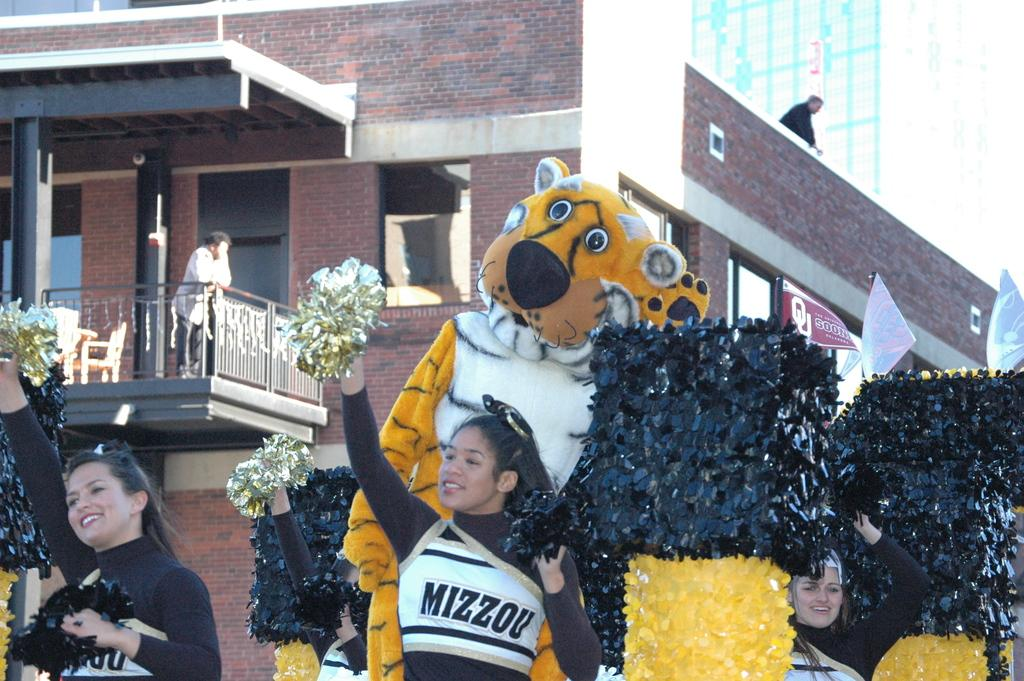<image>
Relay a brief, clear account of the picture shown. Cheerleaders and mascot from Mizzou University on a parade float. 